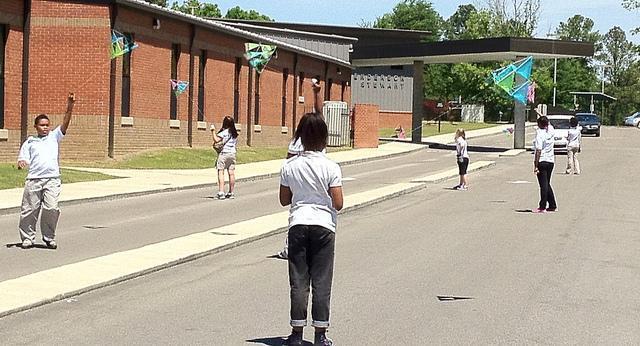How many people can be seen?
Give a very brief answer. 2. 